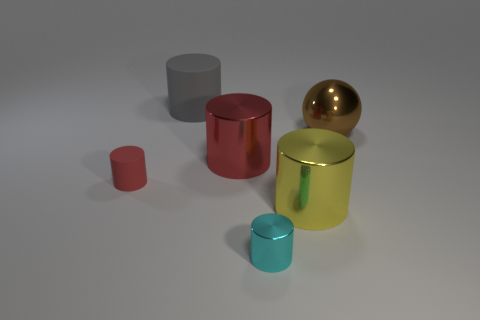Are there fewer purple cylinders than red shiny cylinders?
Keep it short and to the point. Yes. What shape is the thing that is in front of the small red thing and left of the big yellow shiny cylinder?
Your answer should be compact. Cylinder. What number of big gray matte things are there?
Your answer should be compact. 1. There is a small cylinder that is right of the shiny object that is left of the tiny cyan shiny object that is right of the tiny red cylinder; what is it made of?
Your answer should be compact. Metal. What number of large things are right of the large cylinder that is behind the large brown sphere?
Provide a succinct answer. 3. What color is the small matte thing that is the same shape as the big red thing?
Your response must be concise. Red. Are the large yellow thing and the brown ball made of the same material?
Your answer should be very brief. Yes. How many cylinders are either large red shiny objects or rubber things?
Make the answer very short. 3. There is a cyan metallic cylinder in front of the big metal object in front of the red thing that is on the right side of the large gray matte thing; what is its size?
Keep it short and to the point. Small. What is the size of the cyan metallic thing that is the same shape as the gray thing?
Make the answer very short. Small. 